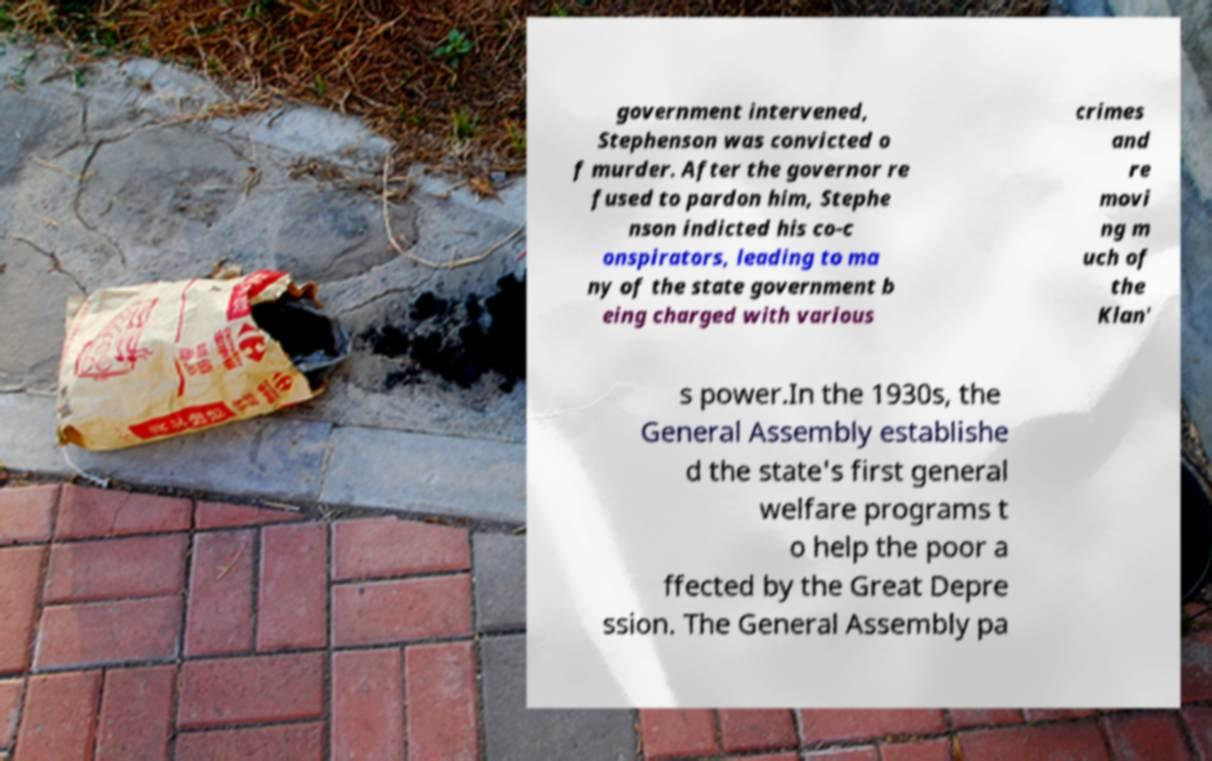There's text embedded in this image that I need extracted. Can you transcribe it verbatim? government intervened, Stephenson was convicted o f murder. After the governor re fused to pardon him, Stephe nson indicted his co-c onspirators, leading to ma ny of the state government b eing charged with various crimes and re movi ng m uch of the Klan' s power.In the 1930s, the General Assembly establishe d the state's first general welfare programs t o help the poor a ffected by the Great Depre ssion. The General Assembly pa 